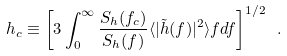<formula> <loc_0><loc_0><loc_500><loc_500>h _ { c } \equiv \left [ 3 \int _ { 0 } ^ { \infty } \frac { S _ { h } ( f _ { c } ) } { S _ { h } ( f ) } \langle | { \tilde { h } } ( f ) | ^ { 2 } \rangle f d f \right ] ^ { 1 / 2 } \ .</formula> 